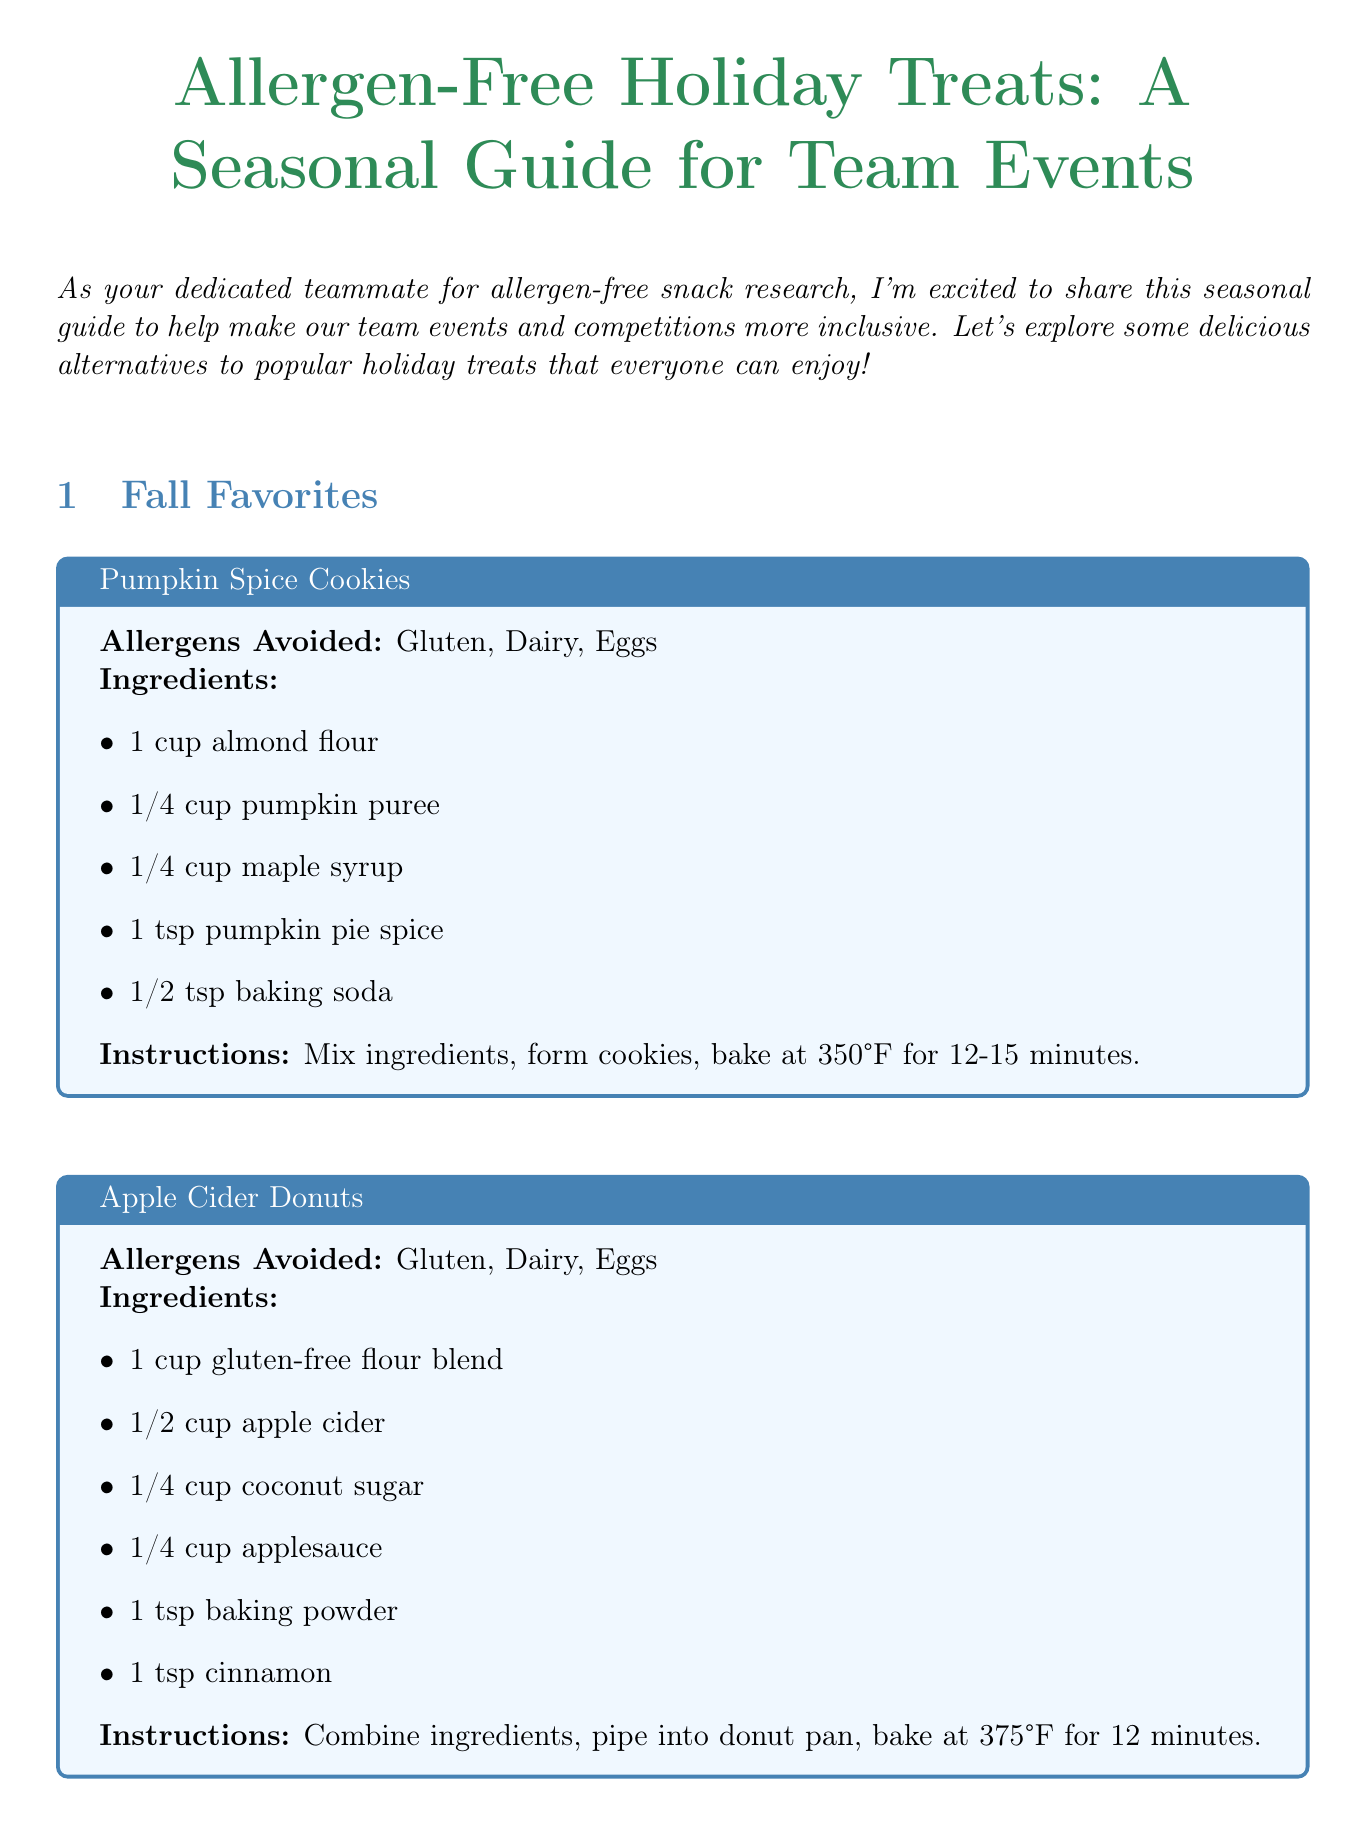What is the title of the newsletter? The title of the newsletter is mentioned at the beginning of the document.
Answer: Allergen-Free Holiday Treats: A Seasonal Guide for Team Events How many sections are in the newsletter? The newsletter contains sections based on seasonal treats. There are four distinct sections.
Answer: 4 What allergens are avoided in Pumpkin Spice Cookies? The allergens avoided are listed under each treat, specifically for Pumpkin Spice Cookies.
Answer: Gluten, Dairy, Eggs What is a key ingredient in Gingerbread People? The recipe for Gingerbread People lists several ingredients, one key ingredient is highlighted in the ingredients list.
Answer: Molasses How long do you bake the Apple Cider Donuts? The baking time is specified in the instructions for Apple Cider Donuts.
Answer: 12 minutes What treat includes strawberries? The specific treat that features strawberries is noted in the section for Spring Delights.
Answer: Strawberry Shortcake Which allergen does Peppermint Hot Chocolate not avoid? The allergens avoided in Peppermint Hot Chocolate are stated clearly, indicating what it does not avoid.
Answer: Soy How are the Watermelon Sorbet ingredients prepared? The method of preparation for Watermelon Sorbet is described in concise steps within the recipe.
Answer: Blend ingredients, freeze for 2 hours, blend again, freeze until firm What is the conclusion about allergen-free alternatives? The conclusion summarizes the importance of allergen-free alternatives for team events.
Answer: Ensure all team members can participate in holiday celebrations without worry 